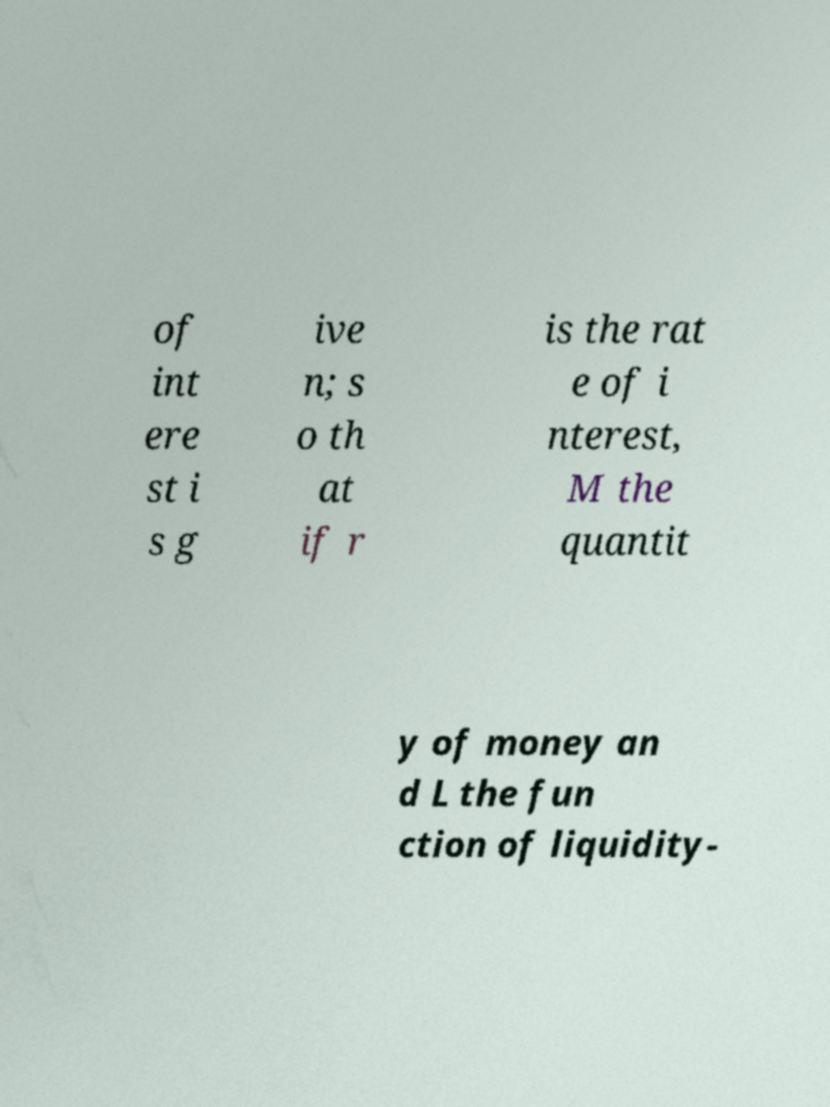Could you assist in decoding the text presented in this image and type it out clearly? of int ere st i s g ive n; s o th at if r is the rat e of i nterest, M the quantit y of money an d L the fun ction of liquidity- 